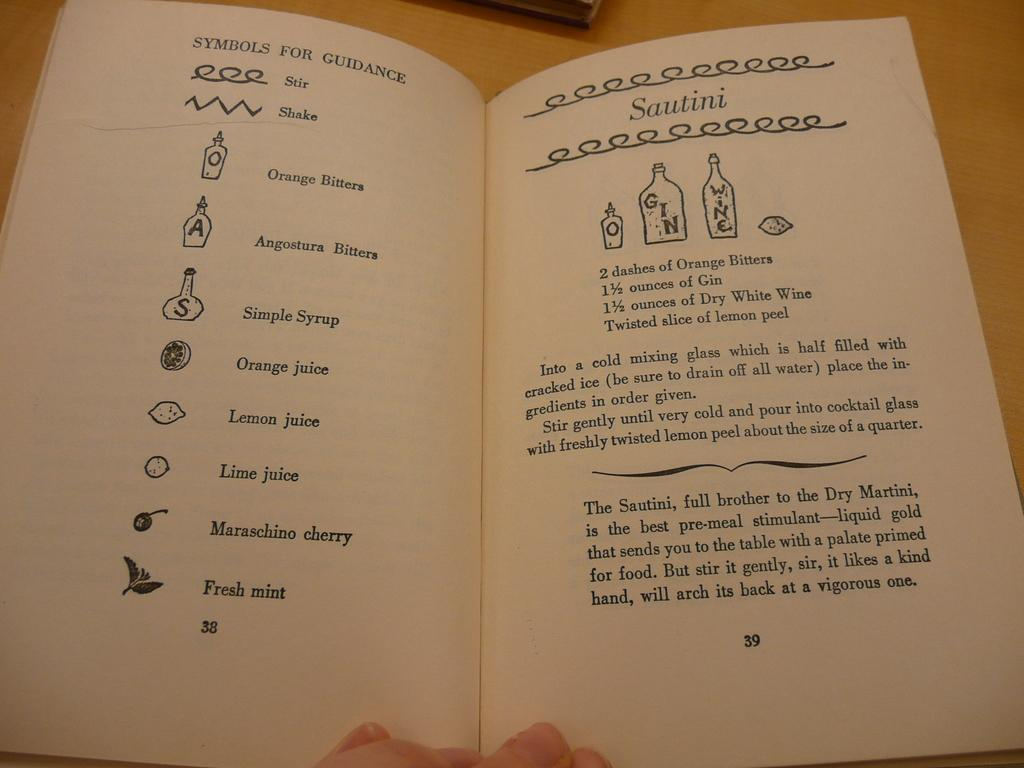<image>
Relay a brief, clear account of the picture shown. A bar tending book explains what the symbols used mean on page 38. 